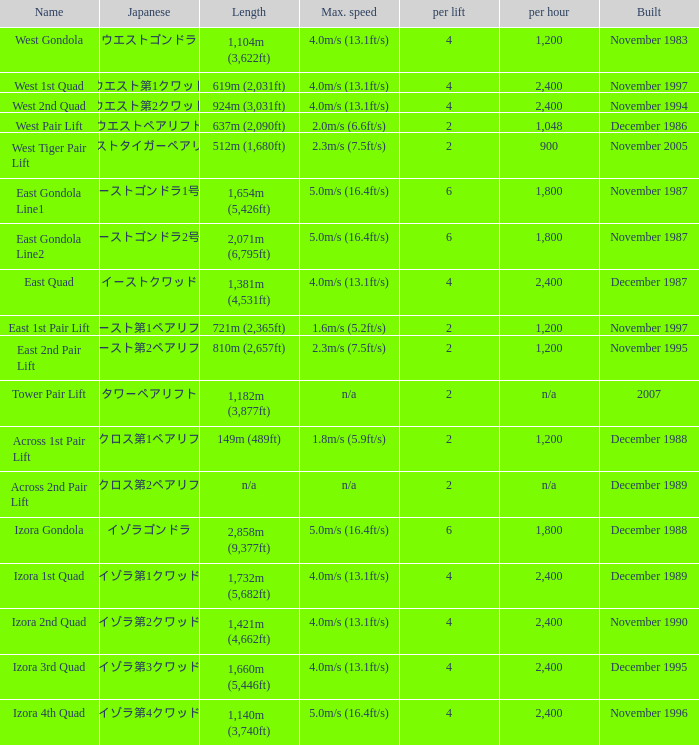What is the maximum weight? 6.0. 